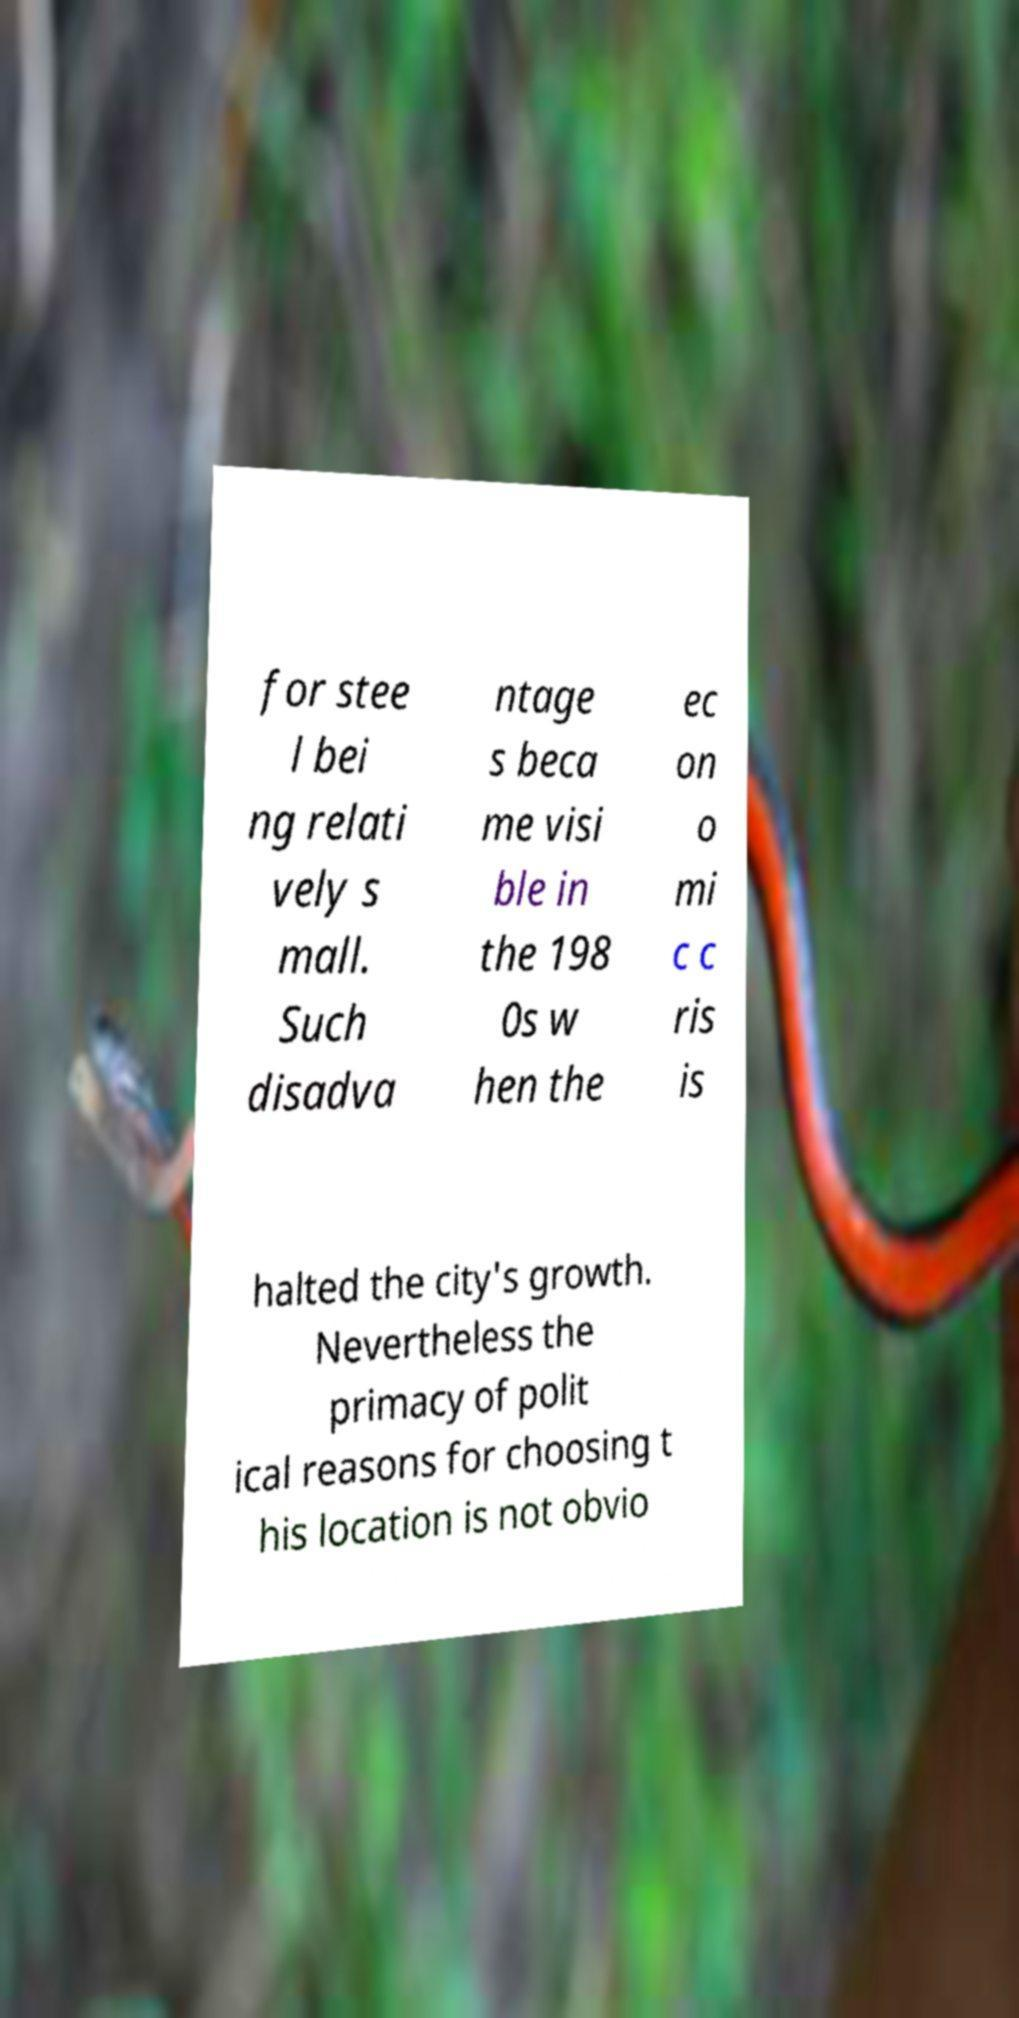Please identify and transcribe the text found in this image. for stee l bei ng relati vely s mall. Such disadva ntage s beca me visi ble in the 198 0s w hen the ec on o mi c c ris is halted the city's growth. Nevertheless the primacy of polit ical reasons for choosing t his location is not obvio 